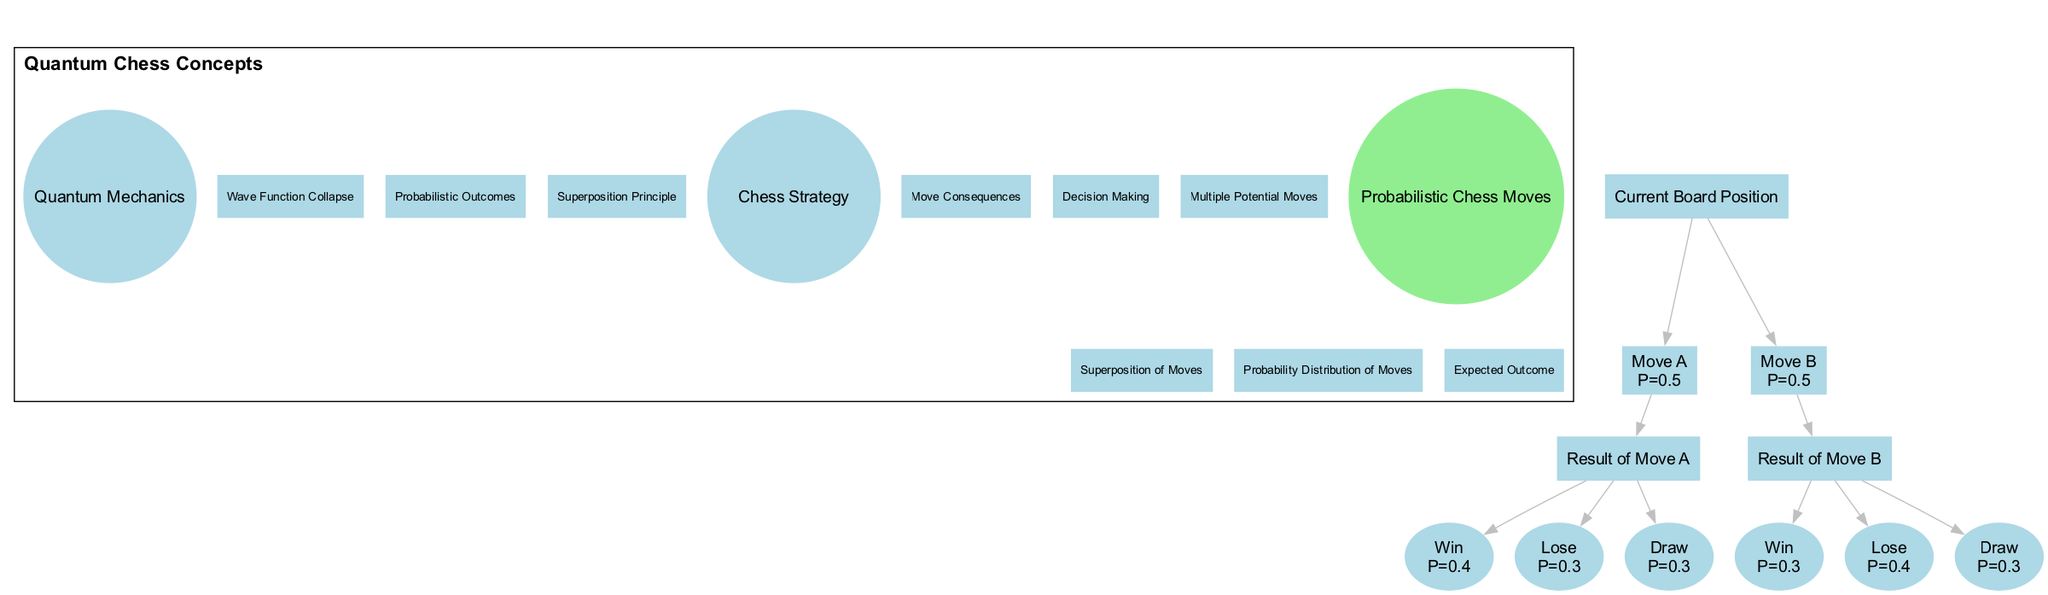What are the three elements in the "Quantum Mechanics" circle? The "Quantum Mechanics" circle contains three elements: "Superposition Principle," "Probabilistic Outcomes," and "Wave Function Collapse." These elements are listed directly within the circle according to the diagram.
Answer: Superposition Principle, Probabilistic Outcomes, Wave Function Collapse How many children nodes are under the "Current Board Position"? There are two children nodes listed under the "Current Board Position," which are "Move A" and "Move B." This information is derived from the structure of the probabilistic tree in the diagram.
Answer: 2 What is the probability of "Move B"? The probability associated with "Move B" is 0.5, as noted directly in the diagram where each move lists its respective probability.
Answer: 0.5 Which move has a higher probability of winning, "Move A" or "Move B"? "Move A" has a winning probability of 0.4 while "Move B" has a winning probability of 0.3. Thus, "Move A" has a higher probability of winning, derived from an analysis of the outcomes listed under each move's results.
Answer: Move A What is the intersection of Quantum Mechanics and Chess Strategy called? The intersection of Quantum Mechanics and Chess Strategy is called "Probabilistic Chess Moves," as indicated in the intersection section of the Venn diagram. This is where the principles of both fields converge in the context of chess.
Answer: Probabilistic Chess Moves What is the probability of losing after making "Move A"? The probability of losing after making "Move A" is 0.3. This is explicitly stated in the outcome section for "Move A" in the probabilistic tree of the diagram.
Answer: 0.3 Which element in the intersection represents the distribution of chess moves? The element that represents the distribution of chess moves in the intersection is "Probability Distribution of Moves." This is noted in the intersection area of the Venn diagram where shared concepts are listed.
Answer: Probability Distribution of Moves What is the total probability of drawing for both moves combined? The total probability of drawing for both "Move A" and "Move B" is 0.3 (from "Move A") + 0.3 (from "Move B") = 0.6. This calculation requires summing the individual probabilities of drawing from both outcomes.
Answer: 0.6 What is the label for the root of the probabilistic tree? The root of the probabilistic tree is labeled "Current Board Position." This information is indicated at the top of the tree structure as the starting point for decision-making in chess.
Answer: Current Board Position 